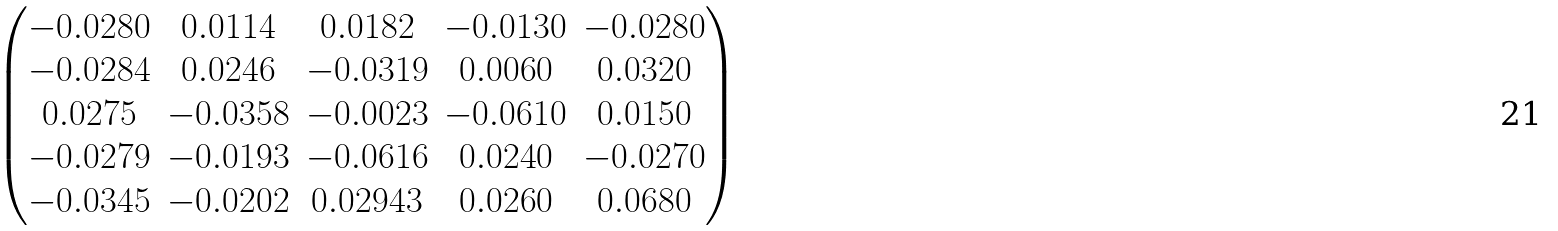Convert formula to latex. <formula><loc_0><loc_0><loc_500><loc_500>\begin{pmatrix} - 0 . 0 2 8 0 & 0 . 0 1 1 4 & 0 . 0 1 8 2 & - 0 . 0 1 3 0 & - 0 . 0 2 8 0 \\ - 0 . 0 2 8 4 & 0 . 0 2 4 6 & - 0 . 0 3 1 9 & 0 . 0 0 6 0 & 0 . 0 3 2 0 \\ 0 . 0 2 7 5 & - 0 . 0 3 5 8 & - 0 . 0 0 2 3 & - 0 . 0 6 1 0 & 0 . 0 1 5 0 \\ - 0 . 0 2 7 9 & - 0 . 0 1 9 3 & - 0 . 0 6 1 6 & 0 . 0 2 4 0 & - 0 . 0 2 7 0 \\ - 0 . 0 3 4 5 & - 0 . 0 2 0 2 & 0 . 0 2 9 4 3 & 0 . 0 2 6 0 & 0 . 0 6 8 0 \end{pmatrix}</formula> 